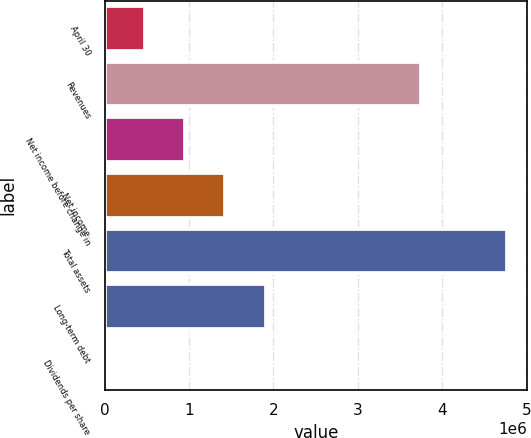<chart> <loc_0><loc_0><loc_500><loc_500><bar_chart><fcel>April 30<fcel>Revenues<fcel>Net income before change in<fcel>Net income<fcel>Total assets<fcel>Long-term debt<fcel>Dividends per share<nl><fcel>476731<fcel>3.74646e+06<fcel>953462<fcel>1.43019e+06<fcel>4.76731e+06<fcel>1.90692e+06<fcel>0.7<nl></chart> 